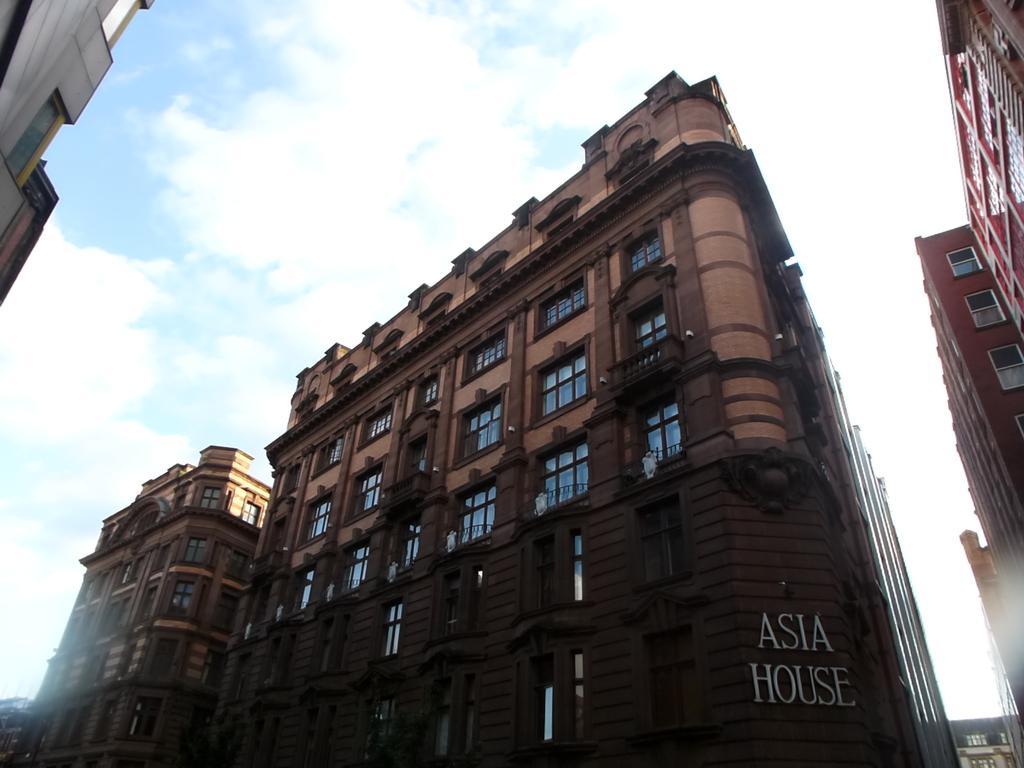In one or two sentences, can you explain what this image depicts? In this image in the center there is a building, and on the right side and left side also there are buildings and on the building there is text in the center. And at the top there is sky. 